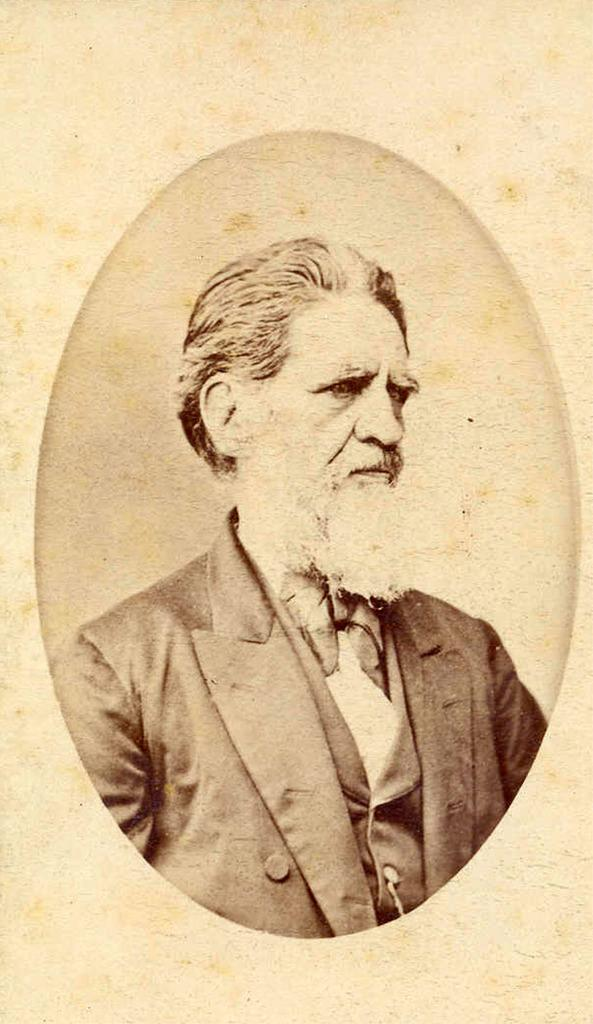What is the shape of the image in the middle of the larger image? The image in the middle of the larger image is ellipse-shaped. What can be seen inside the ellipse-shaped image? The ellipse-shaped image contains a person. What is the person wearing in the image? The person is wearing a suit. What type of stew is being served in the image? There is no stew present in the image; it features an ellipse-shaped image containing a person wearing a suit. 